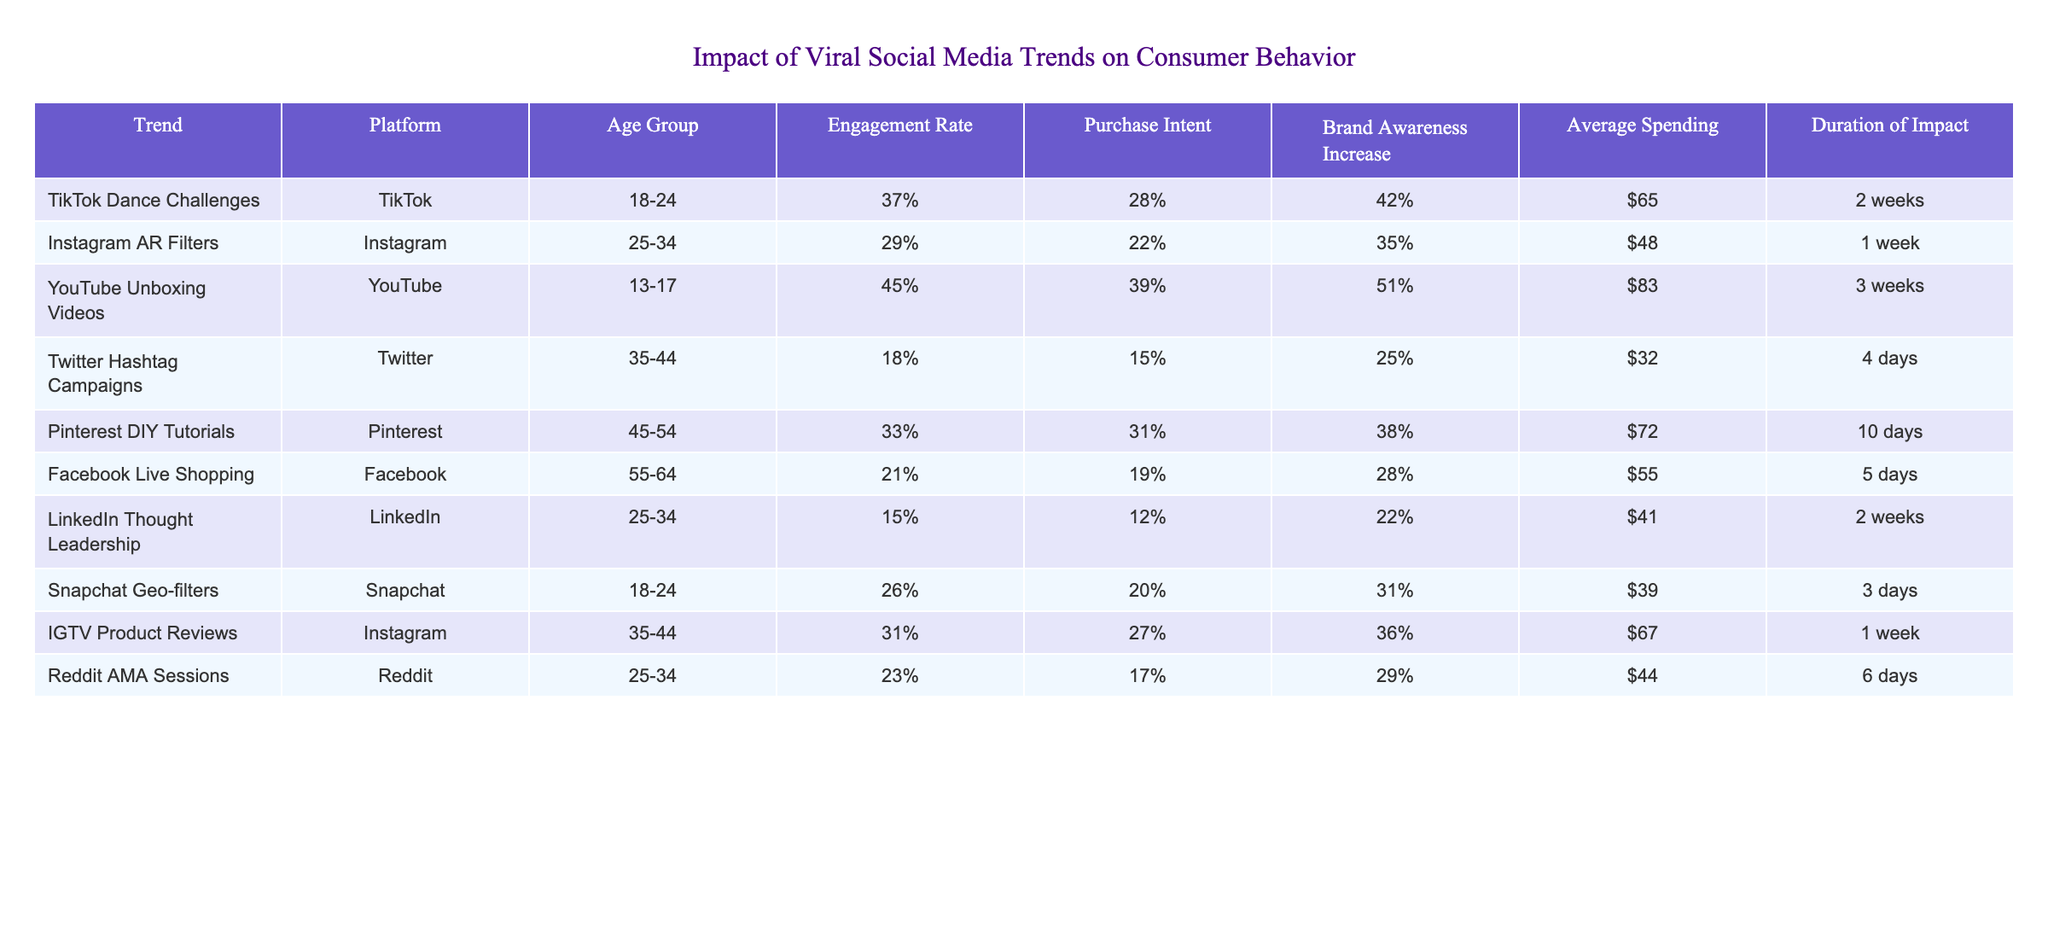What is the engagement rate of TikTok Dance Challenges? According to the table, the engagement rate for TikTok Dance Challenges is listed as 37%.
Answer: 37% Which trend has the highest average spending? The table shows that YouTube Unboxing Videos have the highest average spending at $83 compared to other trends.
Answer: $83 Is the purchase intent for Instagram AR Filters greater than for Twitter Hashtag Campaigns? The purchase intent for Instagram AR Filters is 22%, while for Twitter Hashtag Campaigns, it is 15%. Since 22% is greater than 15%, the statement is true.
Answer: Yes What is the duration of impact for Pinterest DIY Tutorials? The duration of impact for Pinterest DIY Tutorials is specified as 10 days in the table.
Answer: 10 days Which age group has the highest engagement rate and what is that rate? By comparing the engagement rates in the table, the age group 13-17 has the highest engagement rate of 45% from YouTube Unboxing Videos.
Answer: 45% What is the average purchase intent for the age group 25-34? The purchase intents for the age group 25-34 are 22% (Instagram AR Filters), 12% (LinkedIn Thought Leadership), and 17% (Reddit AMA Sessions). Adding these gives 22 + 12 + 17 = 51%, and dividing by 3 gives an average of 17%.
Answer: 17% Are Snapchat Geo-filters more impactful in terms of brand awareness increase compared to Facebook Live Shopping? Snapchat Geo-filters have a brand awareness increase of 31%, while Facebook Live Shopping has 28%. Since 31% is greater than 28%, the statement is true.
Answer: Yes What is the relationship between average spending and engagement rate for trends on Instagram? The average spending for Instagram AR Filters is $48 with an engagement rate of 29%, while for IGTV Product Reviews, it is $67 with a 31% engagement rate. Analyzing these values, spending increases with engagement but not linearly.
Answer: Increasing trend but not linear Which trend has the lowest purchase intent, and what is that percentage? The trend with the lowest purchase intent is Twitter Hashtag Campaigns at 15%.
Answer: 15% How does the brand awareness increase for TikTok Dance Challenges compare to the average across all trends? The brand awareness increase for TikTok Dance Challenges is 42%. To find the average brand awareness increase, we add all the percentages: 42 + 35 + 51 + 25 + 38 + 28 + 22 + 31 + 29 = 351%, and then divide by the number of trends (9), resulting in an average of approximately 39%. Since 42% is above the average, the comparison is higher than average.
Answer: Higher than average 